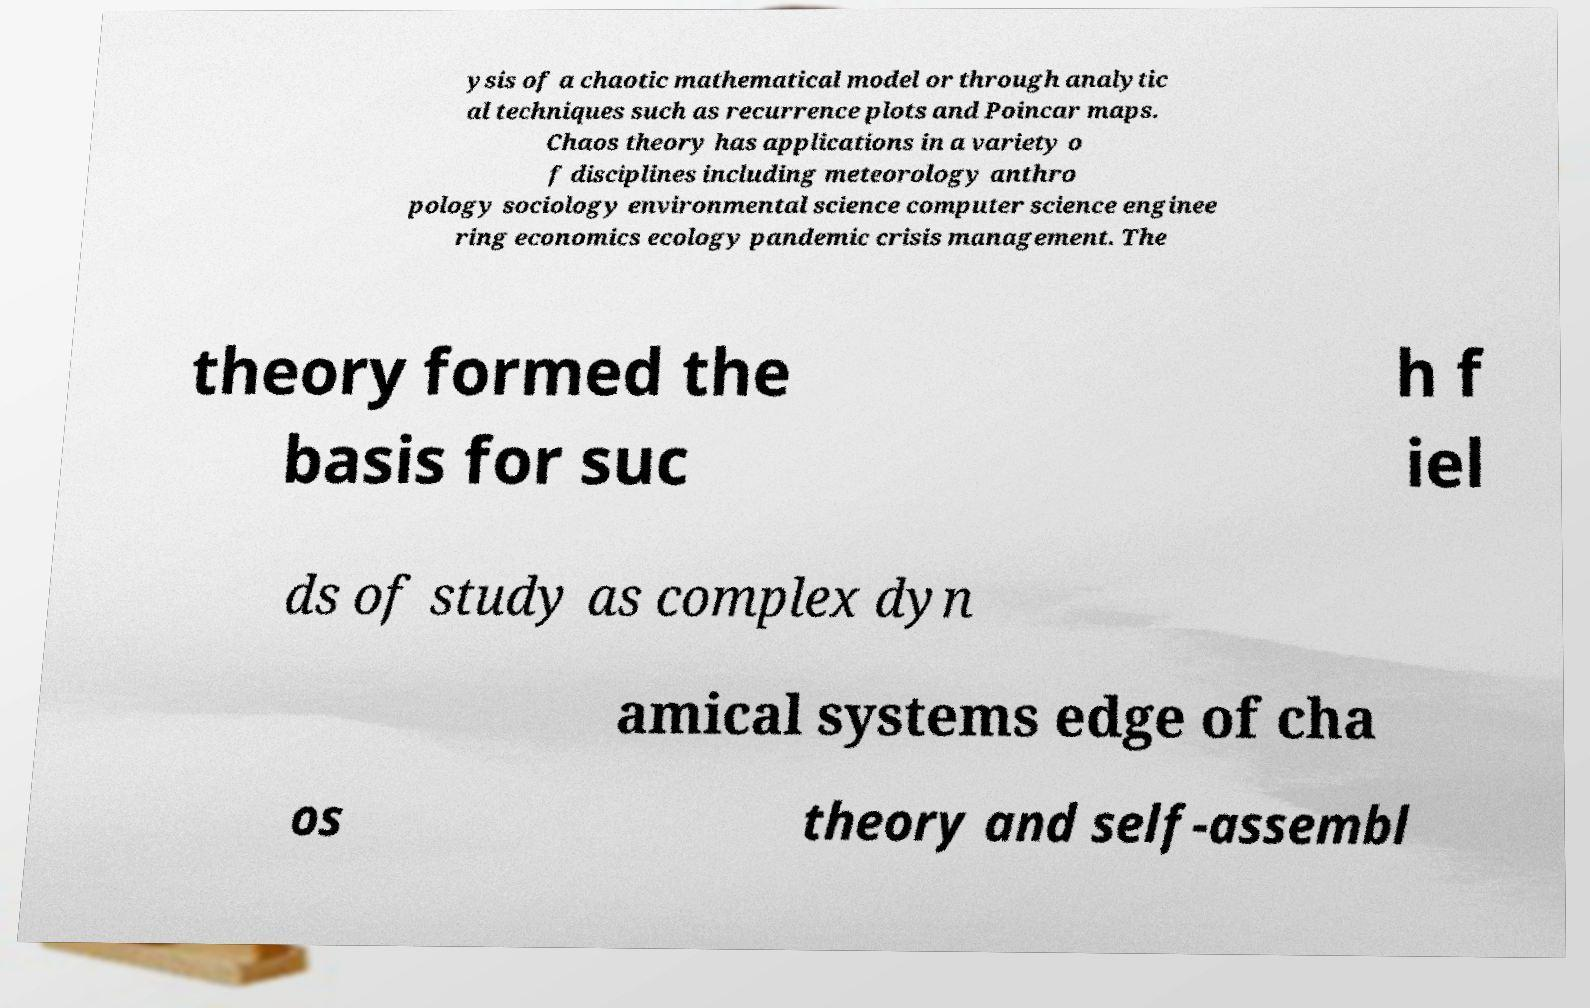There's text embedded in this image that I need extracted. Can you transcribe it verbatim? ysis of a chaotic mathematical model or through analytic al techniques such as recurrence plots and Poincar maps. Chaos theory has applications in a variety o f disciplines including meteorology anthro pology sociology environmental science computer science enginee ring economics ecology pandemic crisis management. The theory formed the basis for suc h f iel ds of study as complex dyn amical systems edge of cha os theory and self-assembl 